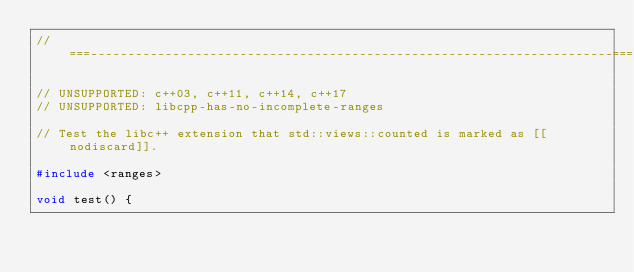<code> <loc_0><loc_0><loc_500><loc_500><_C++_>//===----------------------------------------------------------------------===//

// UNSUPPORTED: c++03, c++11, c++14, c++17
// UNSUPPORTED: libcpp-has-no-incomplete-ranges

// Test the libc++ extension that std::views::counted is marked as [[nodiscard]].

#include <ranges>

void test() {</code> 